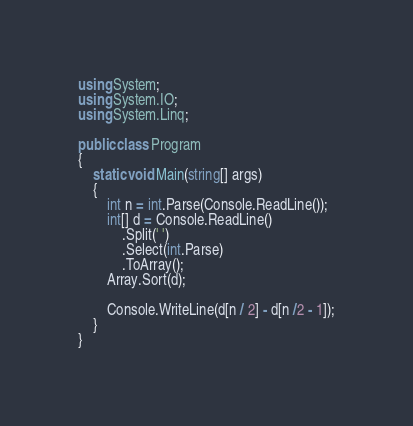<code> <loc_0><loc_0><loc_500><loc_500><_C#_>using System;
using System.IO;
using System.Linq;

public class Program
{
    static void Main(string[] args)
    {
        int n = int.Parse(Console.ReadLine());
        int[] d = Console.ReadLine()
            .Split(' ')
            .Select(int.Parse)
            .ToArray();
        Array.Sort(d);

        Console.WriteLine(d[n / 2] - d[n /2 - 1]);
    }
}</code> 